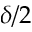Convert formula to latex. <formula><loc_0><loc_0><loc_500><loc_500>\delta / 2</formula> 